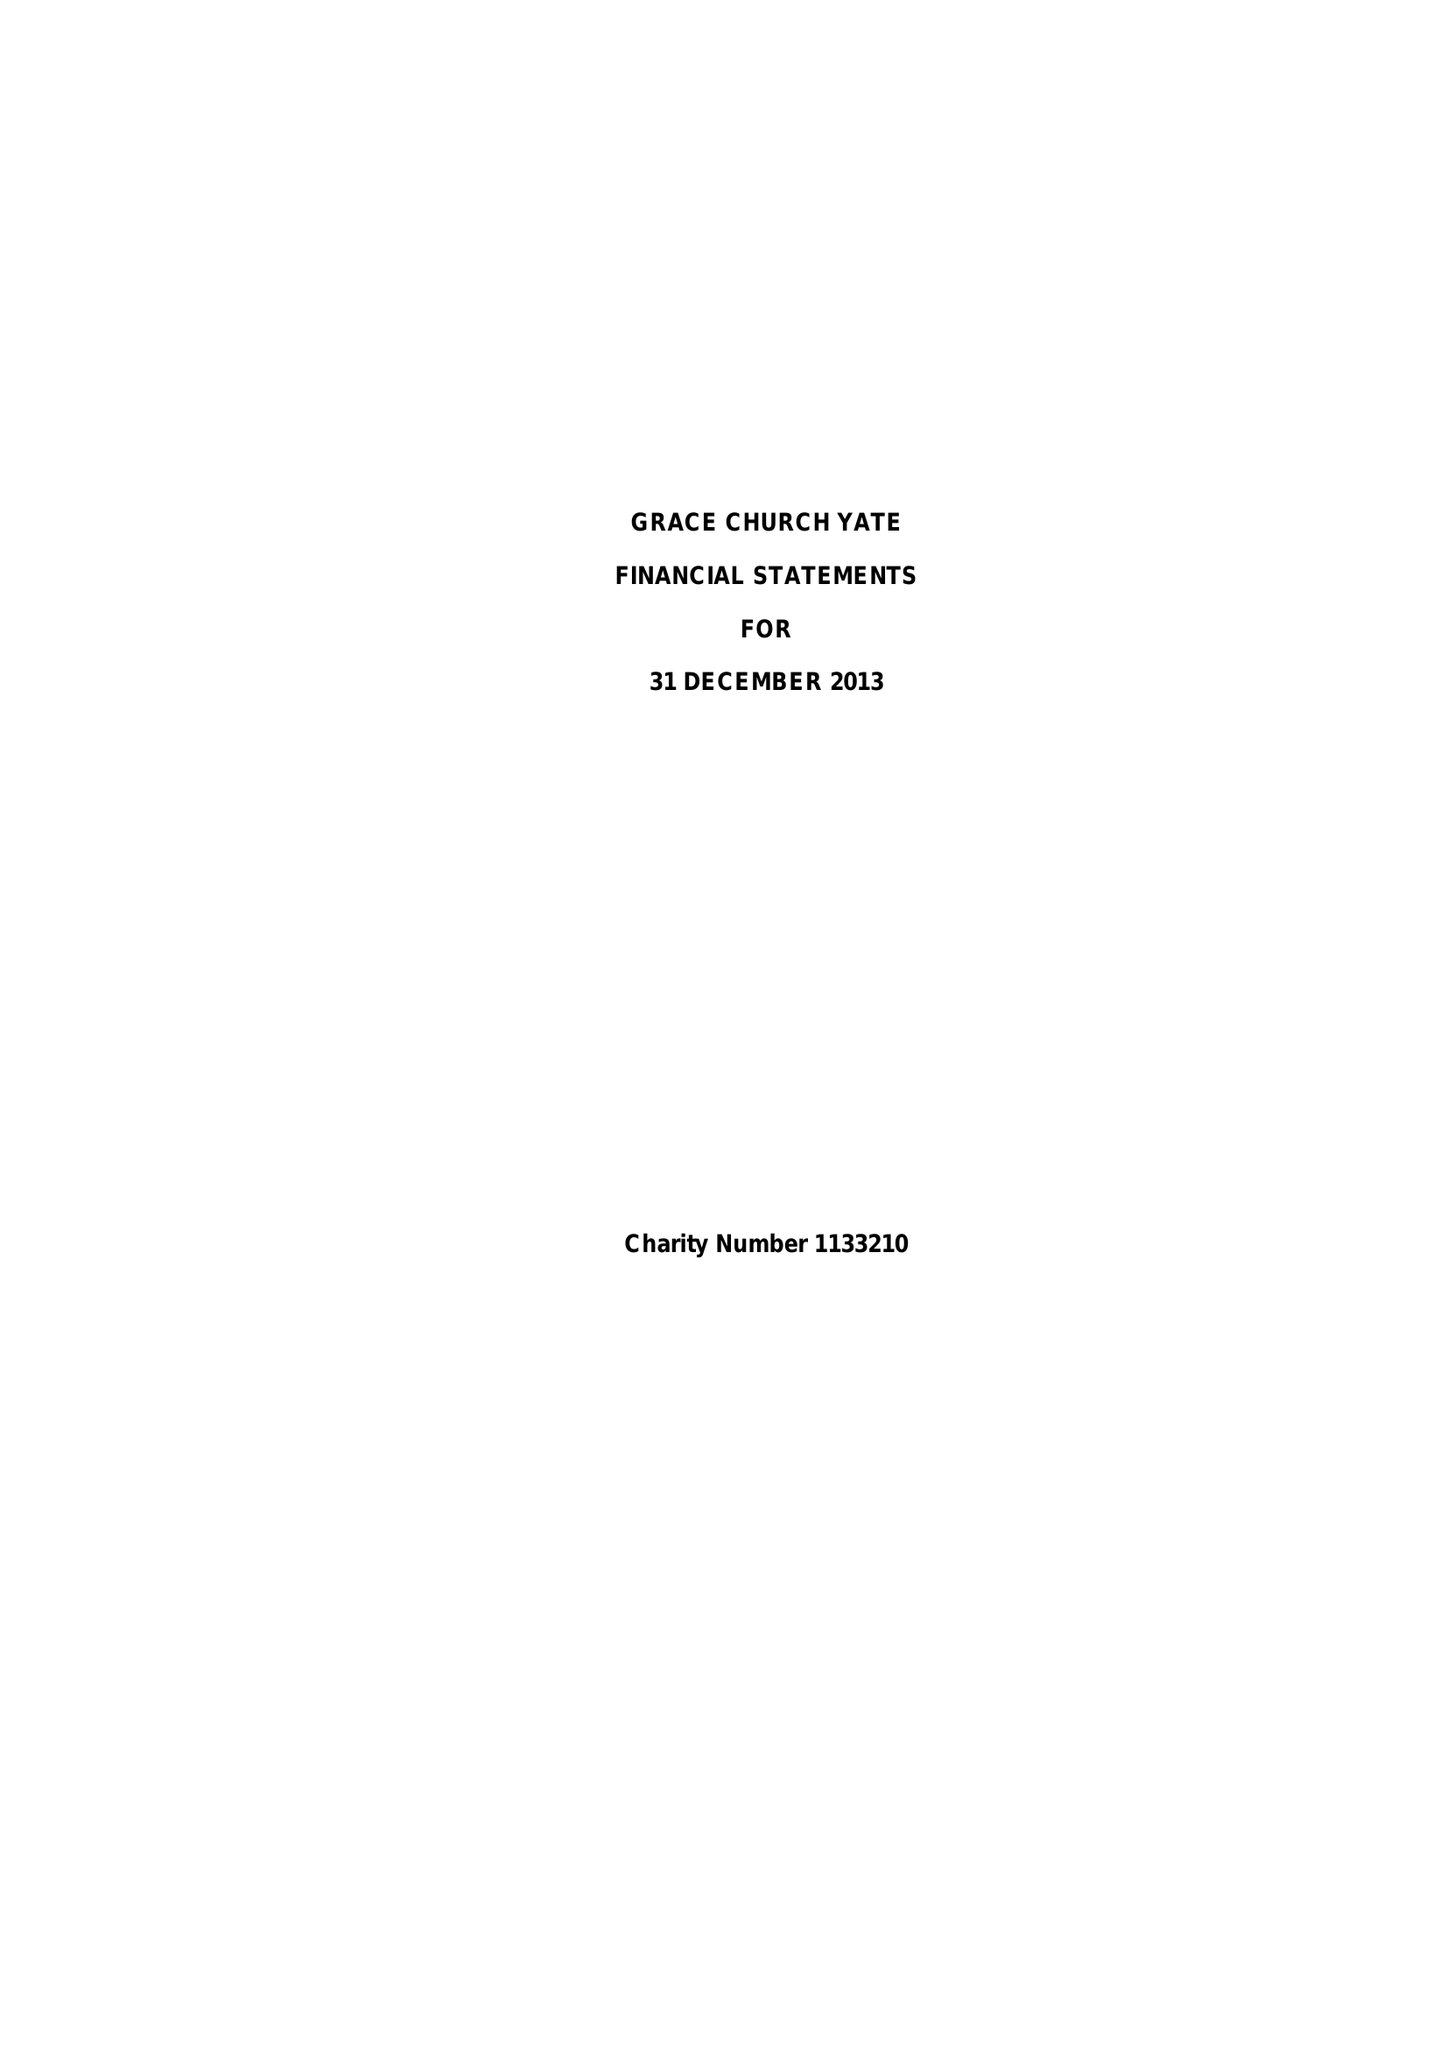What is the value for the address__post_town?
Answer the question using a single word or phrase. BRISTOL 